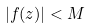<formula> <loc_0><loc_0><loc_500><loc_500>| f ( z ) | < M</formula> 